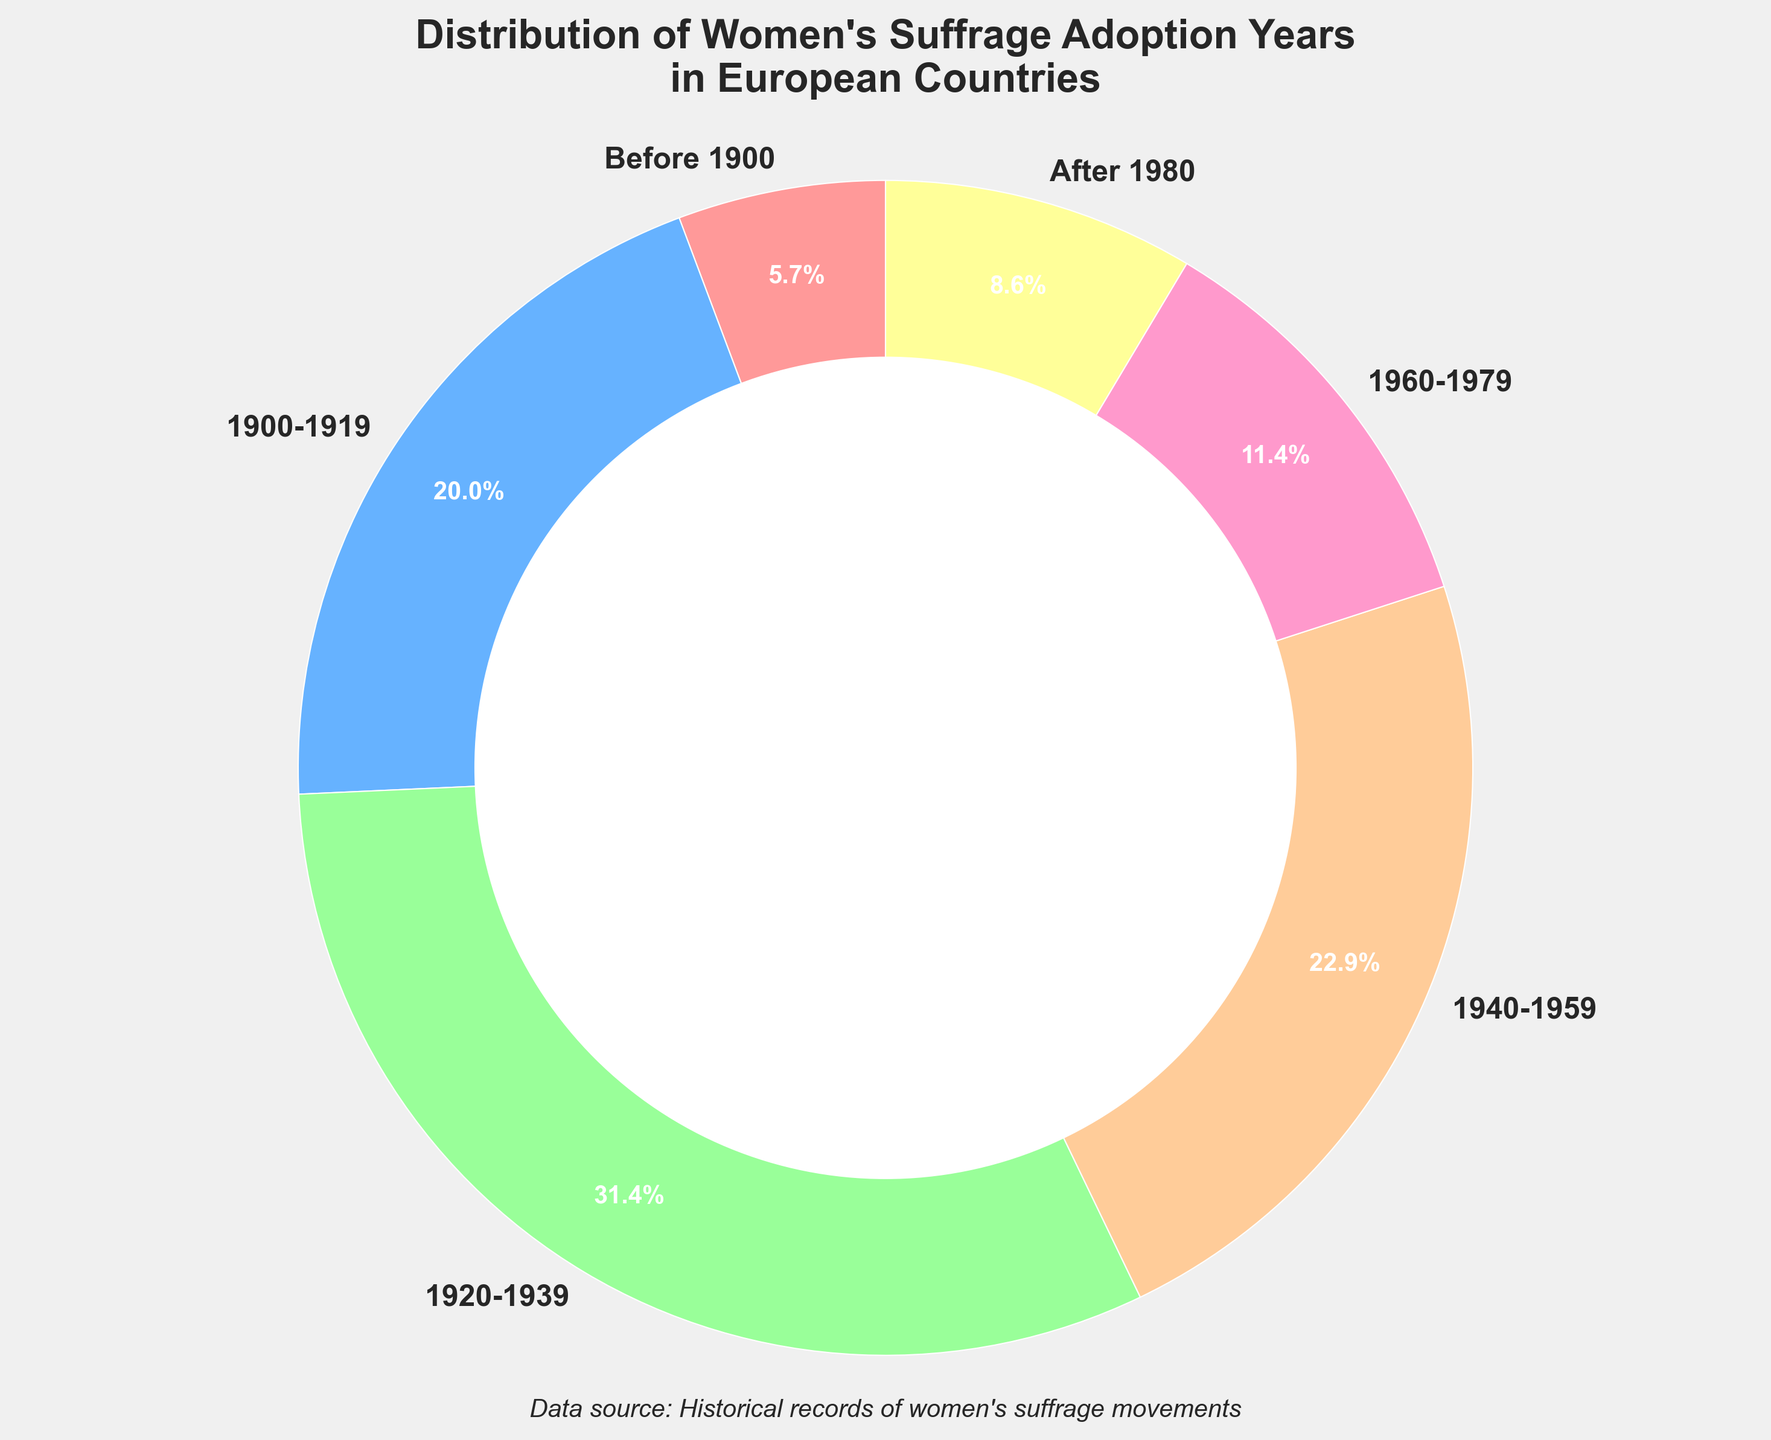Which year range saw the highest adoption of women's suffrage in European countries? To determine the year range with the highest adoption, observe which section of the pie chart has the largest percentage. The segment labeled "1920-1939" covers the highest portion of the chart.
Answer: 1920-1939 How many countries adopted women's suffrage before 1920? According to the pie chart, the year ranges "Before 1900" and "1900-1919" fall before 1920. Adding the countries from both these segments: 2 (Before 1900) + 7 (1900-1919) = 9.
Answer: 9 Which is greater: the number of countries that adopted women's suffrage between 1940-1959 or the number between 1960-1979? The chart shows that 8 countries adopted suffrage between 1940-1959 and 4 countries did so between 1960-1979. Thus, 8 is greater than 4.
Answer: 1940-1959 What's the smallest percentage value shown in the chart and which year range does it represent? To find the smallest percentage, look for the segment with the smallest portion of the chart. The segment labeled "Before 1900" appears smallest, which represents 2 countries out of the total. Calculating (2/35) * 100 gives approximately 5.7%, confirming it as the smallest percentage.
Answer: Before 1900 If you combine all the countries that adopted women's suffrage after 1939, what percentage of the total do they represent? Combine the number of countries from "1940-1959", "1960-1979", and "After 1980": 8 + 4 + 3 = 15. With a total of 35 countries, the percentage is (15/35) * 100, which is approximately 42.9%.
Answer: 42.9% Which segment has a color similar to blue and what year range does it represent? Observing the color scheme of the pie chart, the section similar to blue is represented by the label "1900-1919."
Answer: 1900-1919 If 2 more countries had adopted women's suffrage in the range 1960-1979, what would be the new percentage for this segment? Originally, 4 countries adopted suffrage between 1960-1979. Adding 2 more gives 6. Thus, the new percentage is (6/35) * 100, which is approximately 17.1%.
Answer: 17.1% Compare the combined total number of countries that adopted women's suffrage in the periods before 1920 and between 1940-1959. Is it greater or lesser than those from 1920-1939 alone? Combining "Before 1900" and "1900-1919" gives 2 + 7 = 9. Combining years "1940-1959" gives 8. Together, this total is 9 + 8 = 17. Comparing with 1920-1939 alone which is 11, 17 is greater than 11.
Answer: Greater 